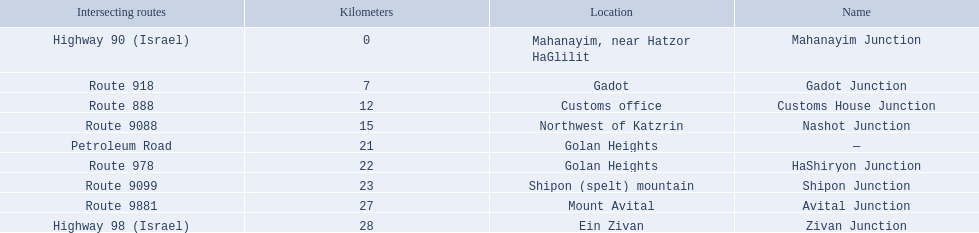Which intersecting routes are route 918 Route 918. What is the name? Gadot Junction. 